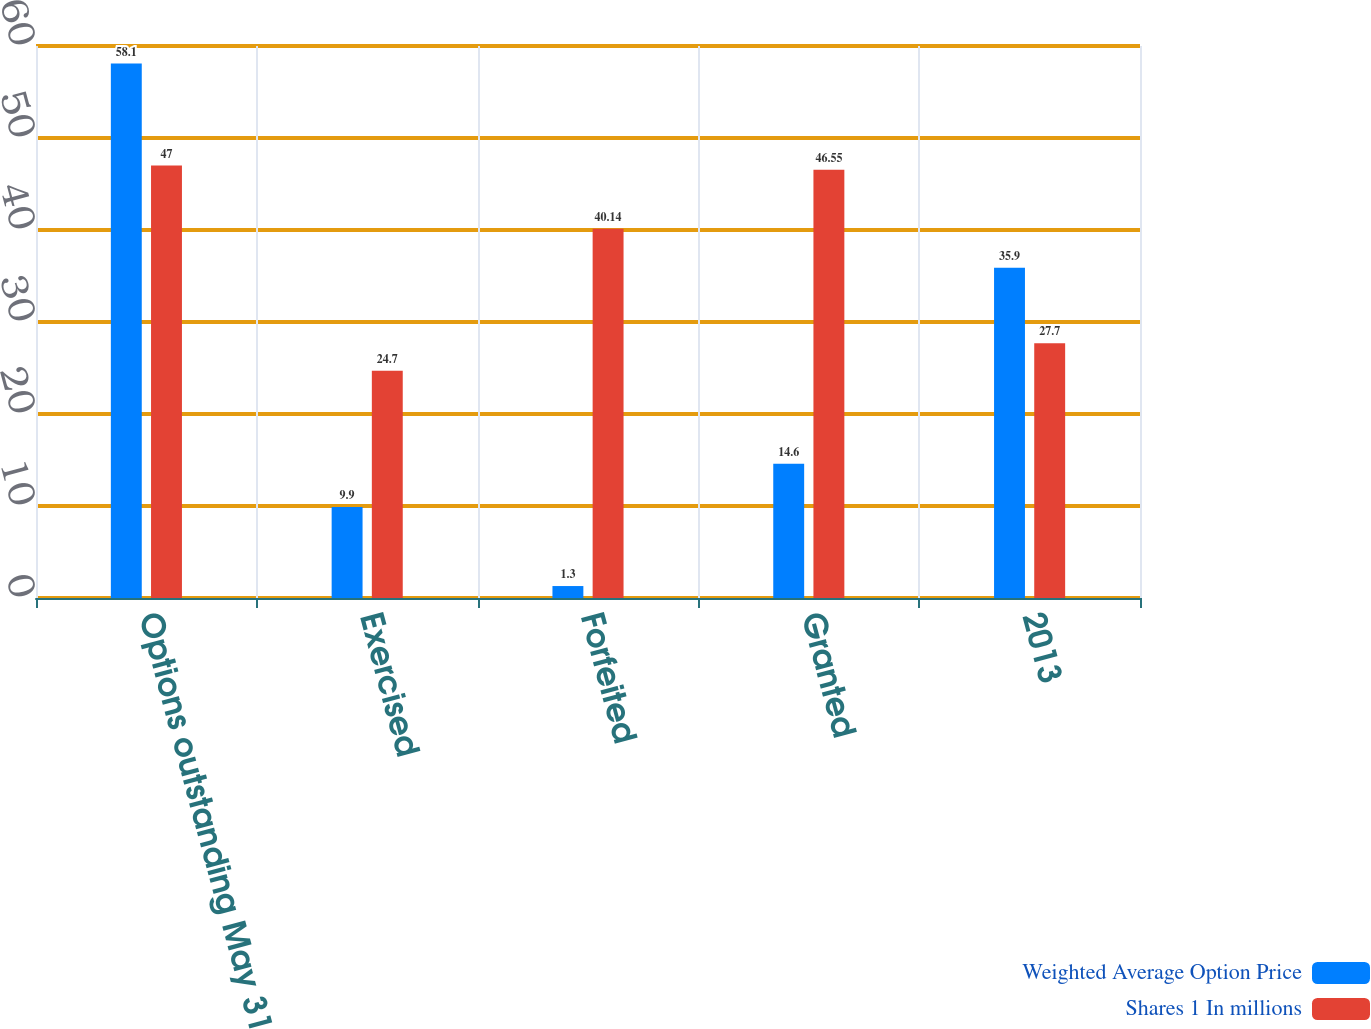Convert chart to OTSL. <chart><loc_0><loc_0><loc_500><loc_500><stacked_bar_chart><ecel><fcel>Options outstanding May 31<fcel>Exercised<fcel>Forfeited<fcel>Granted<fcel>2013<nl><fcel>Weighted Average Option Price<fcel>58.1<fcel>9.9<fcel>1.3<fcel>14.6<fcel>35.9<nl><fcel>Shares 1 In millions<fcel>47<fcel>24.7<fcel>40.14<fcel>46.55<fcel>27.7<nl></chart> 